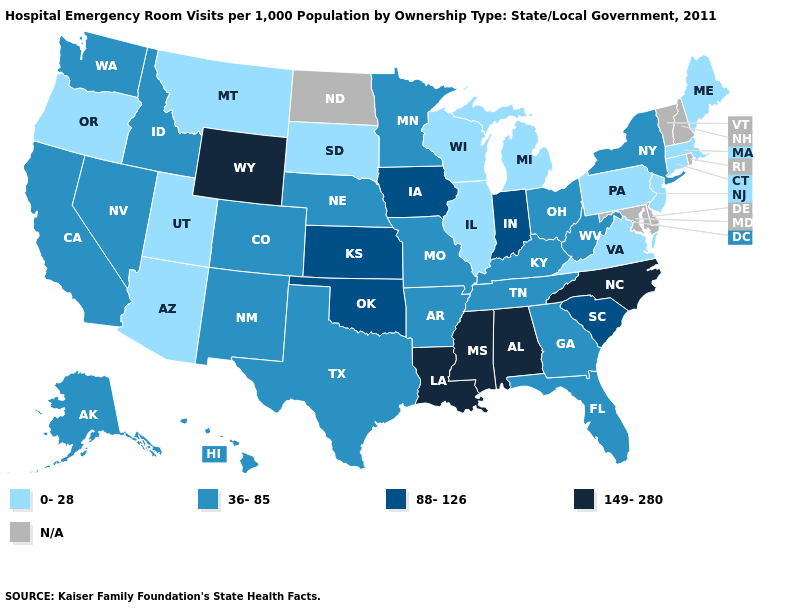Name the states that have a value in the range N/A?
Give a very brief answer. Delaware, Maryland, New Hampshire, North Dakota, Rhode Island, Vermont. Does Iowa have the highest value in the MidWest?
Answer briefly. Yes. What is the value of South Carolina?
Quick response, please. 88-126. What is the value of Montana?
Write a very short answer. 0-28. What is the highest value in states that border Utah?
Quick response, please. 149-280. Name the states that have a value in the range N/A?
Keep it brief. Delaware, Maryland, New Hampshire, North Dakota, Rhode Island, Vermont. Which states have the highest value in the USA?
Answer briefly. Alabama, Louisiana, Mississippi, North Carolina, Wyoming. What is the value of Wyoming?
Be succinct. 149-280. What is the highest value in the USA?
Short answer required. 149-280. Name the states that have a value in the range N/A?
Keep it brief. Delaware, Maryland, New Hampshire, North Dakota, Rhode Island, Vermont. Which states have the highest value in the USA?
Answer briefly. Alabama, Louisiana, Mississippi, North Carolina, Wyoming. Does Alabama have the highest value in the USA?
Answer briefly. Yes. Name the states that have a value in the range 0-28?
Keep it brief. Arizona, Connecticut, Illinois, Maine, Massachusetts, Michigan, Montana, New Jersey, Oregon, Pennsylvania, South Dakota, Utah, Virginia, Wisconsin. 